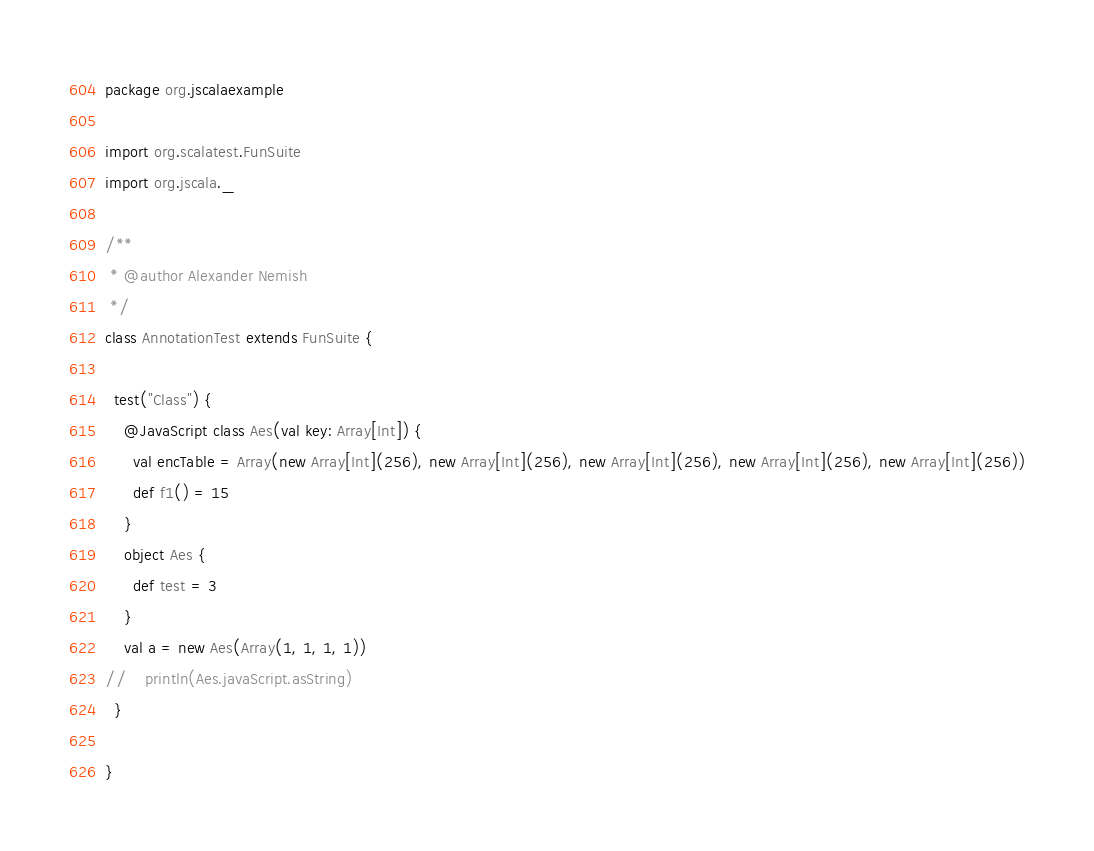<code> <loc_0><loc_0><loc_500><loc_500><_Scala_>package org.jscalaexample

import org.scalatest.FunSuite
import org.jscala._

/**
 * @author Alexander Nemish
 */
class AnnotationTest extends FunSuite {

  test("Class") {
    @JavaScript class Aes(val key: Array[Int]) {
      val encTable = Array(new Array[Int](256), new Array[Int](256), new Array[Int](256), new Array[Int](256), new Array[Int](256))
      def f1() = 15
    }
    object Aes {
      def test = 3
    }
    val a = new Aes(Array(1, 1, 1, 1)) 
//    println(Aes.javaScript.asString)
  }

}
</code> 